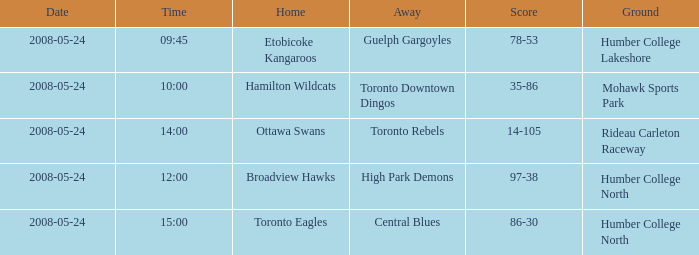Who was the home team of the game at the time of 15:00? Toronto Eagles. 